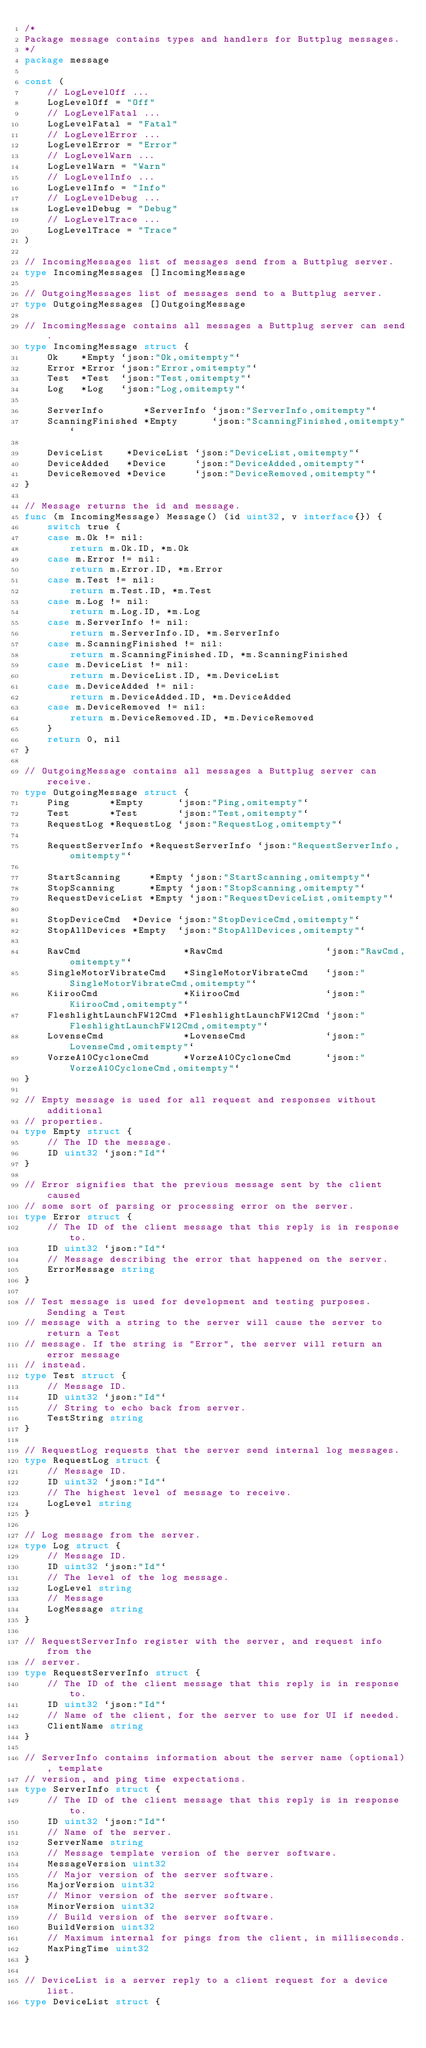Convert code to text. <code><loc_0><loc_0><loc_500><loc_500><_Go_>/*
Package message contains types and handlers for Buttplug messages.
*/
package message

const (
	// LogLevelOff ...
	LogLevelOff = "Off"
	// LogLevelFatal ...
	LogLevelFatal = "Fatal"
	// LogLevelError ...
	LogLevelError = "Error"
	// LogLevelWarn ...
	LogLevelWarn = "Warn"
	// LogLevelInfo ...
	LogLevelInfo = "Info"
	// LogLevelDebug ...
	LogLevelDebug = "Debug"
	// LogLevelTrace ...
	LogLevelTrace = "Trace"
)

// IncomingMessages list of messages send from a Buttplug server.
type IncomingMessages []IncomingMessage

// OutgoingMessages list of messages send to a Buttplug server.
type OutgoingMessages []OutgoingMessage

// IncomingMessage contains all messages a Buttplug server can send.
type IncomingMessage struct {
	Ok    *Empty `json:"Ok,omitempty"`
	Error *Error `json:"Error,omitempty"`
	Test  *Test  `json:"Test,omitempty"`
	Log   *Log   `json:"Log,omitempty"`

	ServerInfo       *ServerInfo `json:"ServerInfo,omitempty"`
	ScanningFinished *Empty      `json:"ScanningFinished,omitempty"`

	DeviceList    *DeviceList `json:"DeviceList,omitempty"`
	DeviceAdded   *Device     `json:"DeviceAdded,omitempty"`
	DeviceRemoved *Device     `json:"DeviceRemoved,omitempty"`
}

// Message returns the id and message.
func (m IncomingMessage) Message() (id uint32, v interface{}) {
	switch true {
	case m.Ok != nil:
		return m.Ok.ID, *m.Ok
	case m.Error != nil:
		return m.Error.ID, *m.Error
	case m.Test != nil:
		return m.Test.ID, *m.Test
	case m.Log != nil:
		return m.Log.ID, *m.Log
	case m.ServerInfo != nil:
		return m.ServerInfo.ID, *m.ServerInfo
	case m.ScanningFinished != nil:
		return m.ScanningFinished.ID, *m.ScanningFinished
	case m.DeviceList != nil:
		return m.DeviceList.ID, *m.DeviceList
	case m.DeviceAdded != nil:
		return m.DeviceAdded.ID, *m.DeviceAdded
	case m.DeviceRemoved != nil:
		return m.DeviceRemoved.ID, *m.DeviceRemoved
	}
	return 0, nil
}

// OutgoingMessage contains all messages a Buttplug server can receive.
type OutgoingMessage struct {
	Ping       *Empty      `json:"Ping,omitempty"`
	Test       *Test       `json:"Test,omitempty"`
	RequestLog *RequestLog `json:"RequestLog,omitempty"`

	RequestServerInfo *RequestServerInfo `json:"RequestServerInfo,omitempty"`

	StartScanning     *Empty `json:"StartScanning,omitempty"`
	StopScanning      *Empty `json:"StopScanning,omitempty"`
	RequestDeviceList *Empty `json:"RequestDeviceList,omitempty"`

	StopDeviceCmd  *Device `json:"StopDeviceCmd,omitempty"`
	StopAllDevices *Empty  `json:"StopAllDevices,omitempty"`

	RawCmd                  *RawCmd                  `json:"RawCmd,omitempty"`
	SingleMotorVibrateCmd   *SingleMotorVibrateCmd   `json:"SingleMotorVibrateCmd,omitempty"`
	KiirooCmd               *KiirooCmd               `json:"KiirooCmd,omitempty"`
	FleshlightLaunchFW12Cmd *FleshlightLaunchFW12Cmd `json:"FleshlightLaunchFW12Cmd,omitempty"`
	LovenseCmd              *LovenseCmd              `json:"LovenseCmd,omitempty"`
	VorzeA10CycloneCmd      *VorzeA10CycloneCmd      `json:"VorzeA10CycloneCmd,omitempty"`
}

// Empty message is used for all request and responses without additional
// properties.
type Empty struct {
	// The ID the message.
	ID uint32 `json:"Id"`
}

// Error signifies that the previous message sent by the client caused
// some sort of parsing or processing error on the server.
type Error struct {
	// The ID of the client message that this reply is in response to.
	ID uint32 `json:"Id"`
	// Message describing the error that happened on the server.
	ErrorMessage string
}

// Test message is used for development and testing purposes. Sending a Test
// message with a string to the server will cause the server to return a Test
// message. If the string is "Error", the server will return an error message
// instead.
type Test struct {
	// Message ID.
	ID uint32 `json:"Id"`
	// String to echo back from server.
	TestString string
}

// RequestLog requests that the server send internal log messages.
type RequestLog struct {
	// Message ID.
	ID uint32 `json:"Id"`
	// The highest level of message to receive.
	LogLevel string
}

// Log message from the server.
type Log struct {
	// Message ID.
	ID uint32 `json:"Id"`
	// The level of the log message.
	LogLevel string
	// Message
	LogMessage string
}

// RequestServerInfo register with the server, and request info from the
// server.
type RequestServerInfo struct {
	// The ID of the client message that this reply is in response to.
	ID uint32 `json:"Id"`
	// Name of the client, for the server to use for UI if needed.
	ClientName string
}

// ServerInfo contains information about the server name (optional), template
// version, and ping time expectations.
type ServerInfo struct {
	// The ID of the client message that this reply is in response to.
	ID uint32 `json:"Id"`
	// Name of the server.
	ServerName string
	// Message template version of the server software.
	MessageVersion uint32
	// Major version of the server software.
	MajorVersion uint32
	// Minor version of the server software.
	MinorVersion uint32
	// Build version of the server software.
	BuildVersion uint32
	// Maximum internal for pings from the client, in milliseconds.
	MaxPingTime uint32
}

// DeviceList is a server reply to a client request for a device list.
type DeviceList struct {</code> 